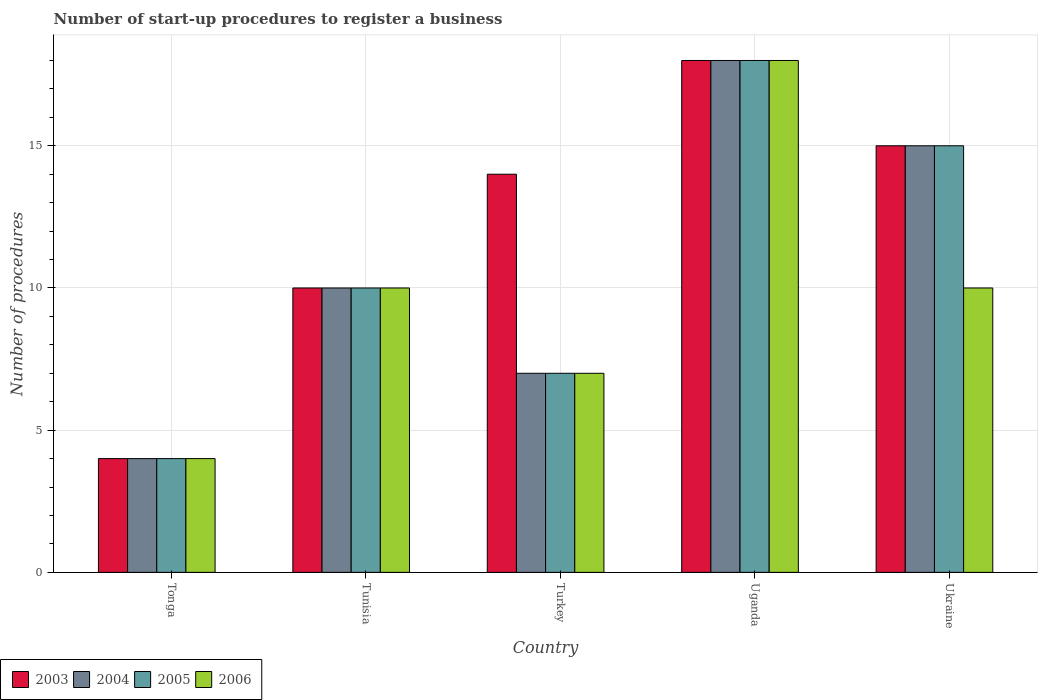How many groups of bars are there?
Give a very brief answer. 5. Are the number of bars on each tick of the X-axis equal?
Make the answer very short. Yes. How many bars are there on the 3rd tick from the left?
Give a very brief answer. 4. What is the label of the 3rd group of bars from the left?
Keep it short and to the point. Turkey. In how many cases, is the number of bars for a given country not equal to the number of legend labels?
Your answer should be very brief. 0. Across all countries, what is the maximum number of procedures required to register a business in 2006?
Your response must be concise. 18. In which country was the number of procedures required to register a business in 2006 maximum?
Make the answer very short. Uganda. In which country was the number of procedures required to register a business in 2003 minimum?
Your response must be concise. Tonga. What is the difference between the number of procedures required to register a business in 2006 in Turkey and that in Ukraine?
Offer a very short reply. -3. What is the difference between the number of procedures required to register a business in 2003 in Ukraine and the number of procedures required to register a business in 2006 in Tunisia?
Offer a very short reply. 5. What is the average number of procedures required to register a business in 2005 per country?
Your answer should be compact. 10.8. What is the ratio of the number of procedures required to register a business in 2004 in Turkey to that in Ukraine?
Offer a terse response. 0.47. Is the number of procedures required to register a business in 2003 in Tunisia less than that in Turkey?
Make the answer very short. Yes. What is the difference between the highest and the lowest number of procedures required to register a business in 2003?
Give a very brief answer. 14. Is it the case that in every country, the sum of the number of procedures required to register a business in 2004 and number of procedures required to register a business in 2003 is greater than the sum of number of procedures required to register a business in 2006 and number of procedures required to register a business in 2005?
Make the answer very short. No. What does the 2nd bar from the left in Ukraine represents?
Keep it short and to the point. 2004. What does the 1st bar from the right in Tunisia represents?
Offer a terse response. 2006. Is it the case that in every country, the sum of the number of procedures required to register a business in 2006 and number of procedures required to register a business in 2003 is greater than the number of procedures required to register a business in 2004?
Keep it short and to the point. Yes. How many bars are there?
Provide a succinct answer. 20. How many countries are there in the graph?
Offer a terse response. 5. What is the difference between two consecutive major ticks on the Y-axis?
Your answer should be compact. 5. Does the graph contain grids?
Your response must be concise. Yes. Where does the legend appear in the graph?
Offer a terse response. Bottom left. What is the title of the graph?
Keep it short and to the point. Number of start-up procedures to register a business. What is the label or title of the X-axis?
Your response must be concise. Country. What is the label or title of the Y-axis?
Provide a succinct answer. Number of procedures. What is the Number of procedures of 2003 in Tonga?
Give a very brief answer. 4. What is the Number of procedures of 2004 in Tonga?
Your answer should be very brief. 4. What is the Number of procedures of 2006 in Tonga?
Provide a succinct answer. 4. What is the Number of procedures of 2005 in Tunisia?
Provide a succinct answer. 10. What is the Number of procedures in 2006 in Tunisia?
Your answer should be compact. 10. What is the Number of procedures of 2003 in Turkey?
Your answer should be very brief. 14. What is the Number of procedures in 2003 in Uganda?
Provide a succinct answer. 18. What is the Number of procedures of 2004 in Uganda?
Ensure brevity in your answer.  18. What is the Number of procedures of 2005 in Uganda?
Offer a very short reply. 18. What is the Number of procedures in 2003 in Ukraine?
Your answer should be compact. 15. What is the Number of procedures in 2006 in Ukraine?
Offer a very short reply. 10. Across all countries, what is the maximum Number of procedures in 2004?
Keep it short and to the point. 18. Across all countries, what is the maximum Number of procedures of 2005?
Your answer should be very brief. 18. Across all countries, what is the maximum Number of procedures in 2006?
Ensure brevity in your answer.  18. Across all countries, what is the minimum Number of procedures in 2005?
Ensure brevity in your answer.  4. What is the total Number of procedures of 2003 in the graph?
Your answer should be very brief. 61. What is the total Number of procedures of 2004 in the graph?
Give a very brief answer. 54. What is the total Number of procedures in 2005 in the graph?
Your response must be concise. 54. What is the total Number of procedures in 2006 in the graph?
Provide a short and direct response. 49. What is the difference between the Number of procedures in 2004 in Tonga and that in Tunisia?
Ensure brevity in your answer.  -6. What is the difference between the Number of procedures of 2006 in Tonga and that in Tunisia?
Keep it short and to the point. -6. What is the difference between the Number of procedures of 2003 in Tonga and that in Turkey?
Ensure brevity in your answer.  -10. What is the difference between the Number of procedures of 2003 in Tonga and that in Uganda?
Offer a very short reply. -14. What is the difference between the Number of procedures of 2004 in Tonga and that in Uganda?
Your answer should be compact. -14. What is the difference between the Number of procedures of 2006 in Tonga and that in Uganda?
Provide a short and direct response. -14. What is the difference between the Number of procedures in 2004 in Tonga and that in Ukraine?
Your answer should be compact. -11. What is the difference between the Number of procedures in 2006 in Tonga and that in Ukraine?
Keep it short and to the point. -6. What is the difference between the Number of procedures in 2003 in Tunisia and that in Turkey?
Your answer should be very brief. -4. What is the difference between the Number of procedures in 2005 in Tunisia and that in Turkey?
Ensure brevity in your answer.  3. What is the difference between the Number of procedures in 2005 in Tunisia and that in Uganda?
Your answer should be compact. -8. What is the difference between the Number of procedures in 2003 in Tunisia and that in Ukraine?
Keep it short and to the point. -5. What is the difference between the Number of procedures in 2005 in Tunisia and that in Ukraine?
Give a very brief answer. -5. What is the difference between the Number of procedures in 2006 in Tunisia and that in Ukraine?
Offer a terse response. 0. What is the difference between the Number of procedures in 2003 in Turkey and that in Uganda?
Offer a very short reply. -4. What is the difference between the Number of procedures in 2005 in Turkey and that in Uganda?
Keep it short and to the point. -11. What is the difference between the Number of procedures of 2006 in Turkey and that in Uganda?
Provide a short and direct response. -11. What is the difference between the Number of procedures of 2005 in Turkey and that in Ukraine?
Your answer should be compact. -8. What is the difference between the Number of procedures of 2003 in Uganda and that in Ukraine?
Offer a very short reply. 3. What is the difference between the Number of procedures in 2005 in Uganda and that in Ukraine?
Provide a succinct answer. 3. What is the difference between the Number of procedures in 2006 in Uganda and that in Ukraine?
Ensure brevity in your answer.  8. What is the difference between the Number of procedures of 2003 in Tonga and the Number of procedures of 2004 in Tunisia?
Offer a terse response. -6. What is the difference between the Number of procedures in 2003 in Tonga and the Number of procedures in 2005 in Tunisia?
Give a very brief answer. -6. What is the difference between the Number of procedures of 2004 in Tonga and the Number of procedures of 2005 in Tunisia?
Give a very brief answer. -6. What is the difference between the Number of procedures of 2004 in Tonga and the Number of procedures of 2006 in Tunisia?
Your response must be concise. -6. What is the difference between the Number of procedures of 2005 in Tonga and the Number of procedures of 2006 in Tunisia?
Make the answer very short. -6. What is the difference between the Number of procedures of 2003 in Tonga and the Number of procedures of 2004 in Turkey?
Provide a short and direct response. -3. What is the difference between the Number of procedures of 2003 in Tonga and the Number of procedures of 2006 in Turkey?
Ensure brevity in your answer.  -3. What is the difference between the Number of procedures of 2004 in Tonga and the Number of procedures of 2005 in Turkey?
Your answer should be very brief. -3. What is the difference between the Number of procedures in 2005 in Tonga and the Number of procedures in 2006 in Turkey?
Ensure brevity in your answer.  -3. What is the difference between the Number of procedures of 2003 in Tonga and the Number of procedures of 2005 in Uganda?
Ensure brevity in your answer.  -14. What is the difference between the Number of procedures in 2004 in Tonga and the Number of procedures in 2006 in Uganda?
Make the answer very short. -14. What is the difference between the Number of procedures in 2005 in Tonga and the Number of procedures in 2006 in Uganda?
Your answer should be very brief. -14. What is the difference between the Number of procedures of 2003 in Tonga and the Number of procedures of 2004 in Ukraine?
Make the answer very short. -11. What is the difference between the Number of procedures in 2003 in Tonga and the Number of procedures in 2006 in Ukraine?
Provide a short and direct response. -6. What is the difference between the Number of procedures of 2003 in Tunisia and the Number of procedures of 2004 in Turkey?
Provide a short and direct response. 3. What is the difference between the Number of procedures of 2003 in Tunisia and the Number of procedures of 2004 in Uganda?
Make the answer very short. -8. What is the difference between the Number of procedures of 2003 in Tunisia and the Number of procedures of 2005 in Uganda?
Your response must be concise. -8. What is the difference between the Number of procedures in 2003 in Tunisia and the Number of procedures in 2006 in Uganda?
Provide a succinct answer. -8. What is the difference between the Number of procedures of 2004 in Tunisia and the Number of procedures of 2005 in Uganda?
Offer a very short reply. -8. What is the difference between the Number of procedures in 2005 in Tunisia and the Number of procedures in 2006 in Uganda?
Give a very brief answer. -8. What is the difference between the Number of procedures of 2003 in Tunisia and the Number of procedures of 2005 in Ukraine?
Give a very brief answer. -5. What is the difference between the Number of procedures of 2003 in Tunisia and the Number of procedures of 2006 in Ukraine?
Make the answer very short. 0. What is the difference between the Number of procedures of 2003 in Turkey and the Number of procedures of 2005 in Uganda?
Provide a succinct answer. -4. What is the difference between the Number of procedures in 2004 in Turkey and the Number of procedures in 2006 in Uganda?
Give a very brief answer. -11. What is the difference between the Number of procedures of 2003 in Turkey and the Number of procedures of 2004 in Ukraine?
Make the answer very short. -1. What is the difference between the Number of procedures of 2003 in Turkey and the Number of procedures of 2005 in Ukraine?
Give a very brief answer. -1. What is the difference between the Number of procedures of 2003 in Turkey and the Number of procedures of 2006 in Ukraine?
Ensure brevity in your answer.  4. What is the difference between the Number of procedures of 2004 in Turkey and the Number of procedures of 2005 in Ukraine?
Ensure brevity in your answer.  -8. What is the difference between the Number of procedures in 2003 in Uganda and the Number of procedures in 2005 in Ukraine?
Provide a short and direct response. 3. What is the difference between the Number of procedures of 2003 in Uganda and the Number of procedures of 2006 in Ukraine?
Offer a terse response. 8. What is the difference between the Number of procedures of 2004 in Uganda and the Number of procedures of 2005 in Ukraine?
Your answer should be compact. 3. What is the average Number of procedures of 2005 per country?
Provide a short and direct response. 10.8. What is the average Number of procedures of 2006 per country?
Keep it short and to the point. 9.8. What is the difference between the Number of procedures in 2004 and Number of procedures in 2006 in Tonga?
Make the answer very short. 0. What is the difference between the Number of procedures in 2004 and Number of procedures in 2005 in Tunisia?
Provide a succinct answer. 0. What is the difference between the Number of procedures of 2004 and Number of procedures of 2006 in Tunisia?
Give a very brief answer. 0. What is the difference between the Number of procedures of 2003 and Number of procedures of 2004 in Turkey?
Your answer should be compact. 7. What is the difference between the Number of procedures of 2003 and Number of procedures of 2005 in Turkey?
Offer a very short reply. 7. What is the difference between the Number of procedures of 2003 and Number of procedures of 2006 in Turkey?
Make the answer very short. 7. What is the difference between the Number of procedures of 2004 and Number of procedures of 2006 in Turkey?
Provide a short and direct response. 0. What is the difference between the Number of procedures of 2003 and Number of procedures of 2004 in Uganda?
Make the answer very short. 0. What is the difference between the Number of procedures in 2003 and Number of procedures in 2005 in Uganda?
Offer a terse response. 0. What is the difference between the Number of procedures of 2004 and Number of procedures of 2005 in Uganda?
Give a very brief answer. 0. What is the difference between the Number of procedures in 2005 and Number of procedures in 2006 in Uganda?
Keep it short and to the point. 0. What is the difference between the Number of procedures in 2003 and Number of procedures in 2004 in Ukraine?
Provide a succinct answer. 0. What is the difference between the Number of procedures of 2003 and Number of procedures of 2005 in Ukraine?
Offer a terse response. 0. What is the difference between the Number of procedures in 2003 and Number of procedures in 2006 in Ukraine?
Provide a short and direct response. 5. What is the difference between the Number of procedures in 2004 and Number of procedures in 2005 in Ukraine?
Your answer should be compact. 0. What is the difference between the Number of procedures of 2005 and Number of procedures of 2006 in Ukraine?
Make the answer very short. 5. What is the ratio of the Number of procedures in 2003 in Tonga to that in Tunisia?
Ensure brevity in your answer.  0.4. What is the ratio of the Number of procedures in 2004 in Tonga to that in Tunisia?
Ensure brevity in your answer.  0.4. What is the ratio of the Number of procedures of 2006 in Tonga to that in Tunisia?
Offer a terse response. 0.4. What is the ratio of the Number of procedures of 2003 in Tonga to that in Turkey?
Provide a short and direct response. 0.29. What is the ratio of the Number of procedures of 2004 in Tonga to that in Turkey?
Make the answer very short. 0.57. What is the ratio of the Number of procedures in 2006 in Tonga to that in Turkey?
Provide a short and direct response. 0.57. What is the ratio of the Number of procedures in 2003 in Tonga to that in Uganda?
Make the answer very short. 0.22. What is the ratio of the Number of procedures in 2004 in Tonga to that in Uganda?
Offer a terse response. 0.22. What is the ratio of the Number of procedures in 2005 in Tonga to that in Uganda?
Offer a terse response. 0.22. What is the ratio of the Number of procedures of 2006 in Tonga to that in Uganda?
Give a very brief answer. 0.22. What is the ratio of the Number of procedures in 2003 in Tonga to that in Ukraine?
Make the answer very short. 0.27. What is the ratio of the Number of procedures of 2004 in Tonga to that in Ukraine?
Keep it short and to the point. 0.27. What is the ratio of the Number of procedures in 2005 in Tonga to that in Ukraine?
Your answer should be very brief. 0.27. What is the ratio of the Number of procedures in 2003 in Tunisia to that in Turkey?
Provide a short and direct response. 0.71. What is the ratio of the Number of procedures in 2004 in Tunisia to that in Turkey?
Give a very brief answer. 1.43. What is the ratio of the Number of procedures of 2005 in Tunisia to that in Turkey?
Provide a short and direct response. 1.43. What is the ratio of the Number of procedures of 2006 in Tunisia to that in Turkey?
Ensure brevity in your answer.  1.43. What is the ratio of the Number of procedures of 2003 in Tunisia to that in Uganda?
Your answer should be compact. 0.56. What is the ratio of the Number of procedures in 2004 in Tunisia to that in Uganda?
Offer a terse response. 0.56. What is the ratio of the Number of procedures in 2005 in Tunisia to that in Uganda?
Keep it short and to the point. 0.56. What is the ratio of the Number of procedures of 2006 in Tunisia to that in Uganda?
Provide a short and direct response. 0.56. What is the ratio of the Number of procedures of 2003 in Tunisia to that in Ukraine?
Offer a very short reply. 0.67. What is the ratio of the Number of procedures in 2004 in Tunisia to that in Ukraine?
Ensure brevity in your answer.  0.67. What is the ratio of the Number of procedures of 2005 in Tunisia to that in Ukraine?
Offer a very short reply. 0.67. What is the ratio of the Number of procedures in 2006 in Tunisia to that in Ukraine?
Give a very brief answer. 1. What is the ratio of the Number of procedures in 2003 in Turkey to that in Uganda?
Give a very brief answer. 0.78. What is the ratio of the Number of procedures in 2004 in Turkey to that in Uganda?
Ensure brevity in your answer.  0.39. What is the ratio of the Number of procedures in 2005 in Turkey to that in Uganda?
Provide a succinct answer. 0.39. What is the ratio of the Number of procedures of 2006 in Turkey to that in Uganda?
Offer a very short reply. 0.39. What is the ratio of the Number of procedures of 2003 in Turkey to that in Ukraine?
Ensure brevity in your answer.  0.93. What is the ratio of the Number of procedures of 2004 in Turkey to that in Ukraine?
Ensure brevity in your answer.  0.47. What is the ratio of the Number of procedures of 2005 in Turkey to that in Ukraine?
Keep it short and to the point. 0.47. What is the ratio of the Number of procedures in 2003 in Uganda to that in Ukraine?
Give a very brief answer. 1.2. What is the ratio of the Number of procedures of 2005 in Uganda to that in Ukraine?
Provide a succinct answer. 1.2. What is the ratio of the Number of procedures in 2006 in Uganda to that in Ukraine?
Offer a terse response. 1.8. What is the difference between the highest and the second highest Number of procedures of 2003?
Make the answer very short. 3. What is the difference between the highest and the second highest Number of procedures in 2004?
Make the answer very short. 3. What is the difference between the highest and the second highest Number of procedures of 2005?
Keep it short and to the point. 3. What is the difference between the highest and the lowest Number of procedures of 2004?
Your answer should be very brief. 14. What is the difference between the highest and the lowest Number of procedures in 2006?
Offer a very short reply. 14. 